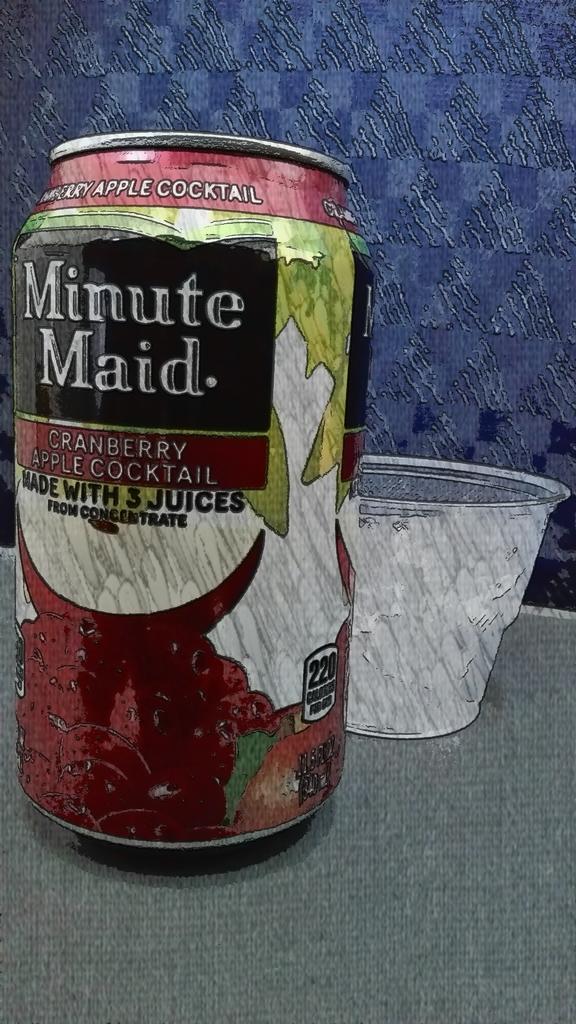What is the name of this drink?
Make the answer very short. Minute maid. 